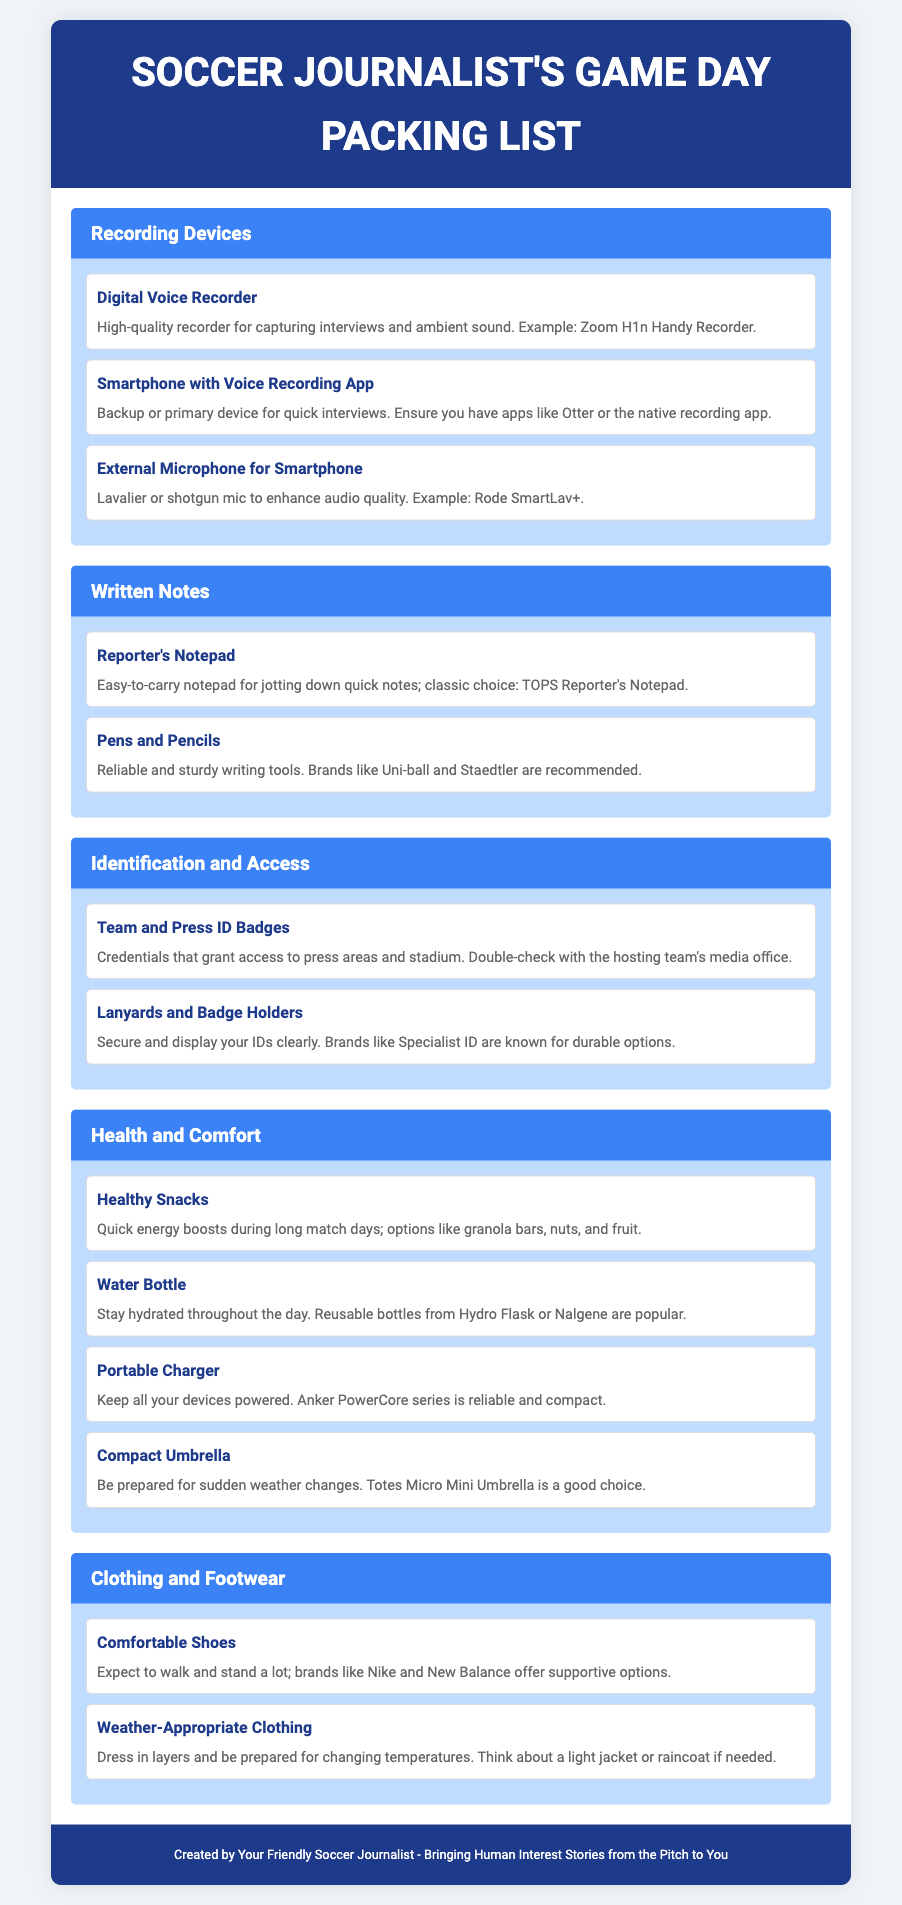What is the title of the document? The title is prominently displayed in the header section of the document.
Answer: Soccer Journalist's Game Day Packing List What is one recommended device for capturing interviews? The document lists specific devices under the Recording Devices category.
Answer: Digital Voice Recorder Which brand is suggested for comfortable shoes? The document mentions specific brands under the Clothing and Footwear category for shoe recommendations.
Answer: Nike How many types of health-related items are listed? The document enumerates items under the Health and Comfort category, including snacks, water bottles, and more.
Answer: Four What color is the background of the header? The styling of the header indicates its color in the document.
Answer: Dark Blue What type of notepad is recommended for written notes? The document specifies the type of notepad suitable for journalists under the Written Notes category.
Answer: Reporter's Notepad Which company provides durable lanyards and badge holders? The document names brands associated with lanyards under the Identification and Access category.
Answer: Specialist ID What is the example product for a portable charger? The document includes specific brand examples under the Health and Comfort category.
Answer: Anker PowerCore series What should be checked with the hosting team's media office? The document suggests an essential item to verify access in the Identification and Access category.
Answer: Team and Press ID Badges 